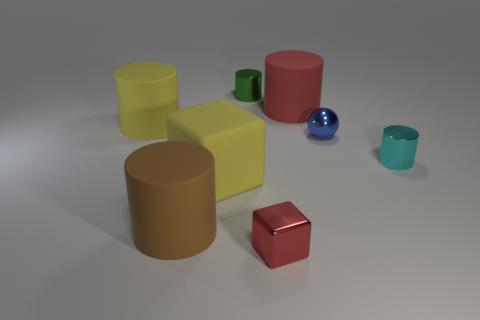There is a large red object that is the same shape as the small green thing; what material is it?
Offer a very short reply. Rubber. There is a sphere; does it have the same color as the tiny metallic cylinder that is on the right side of the green object?
Your answer should be compact. No. The object that is both in front of the cyan shiny object and right of the yellow rubber cube is what color?
Your answer should be very brief. Red. What number of other things are the same material as the brown object?
Your response must be concise. 3. Is the number of metal objects less than the number of green shiny objects?
Keep it short and to the point. No. Is the small cube made of the same material as the small thing that is behind the red matte cylinder?
Ensure brevity in your answer.  Yes. What shape is the metal object that is behind the red rubber cylinder?
Make the answer very short. Cylinder. Is there anything else that has the same color as the shiny sphere?
Offer a terse response. No. Is the number of small cylinders on the left side of the brown object less than the number of large objects?
Provide a succinct answer. Yes. What number of brown matte things are the same size as the blue object?
Provide a succinct answer. 0. 